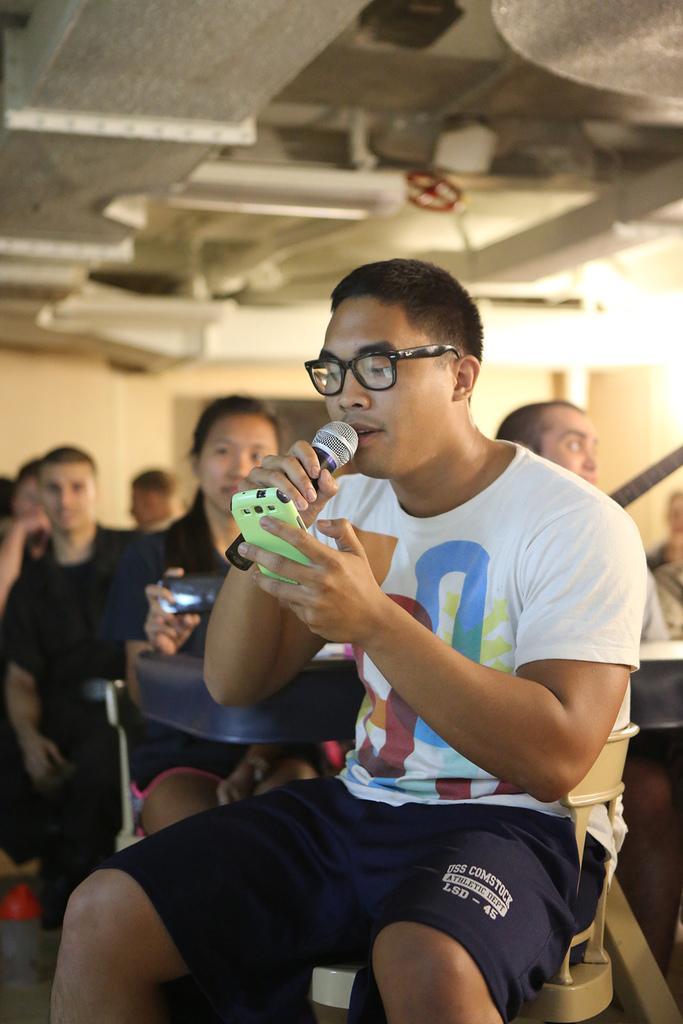In one or two sentences, can you explain what this image depicts? In this image there is a person sitting in chair and holding a microphone and mobile and the back ground there are group of people sitting and light. 